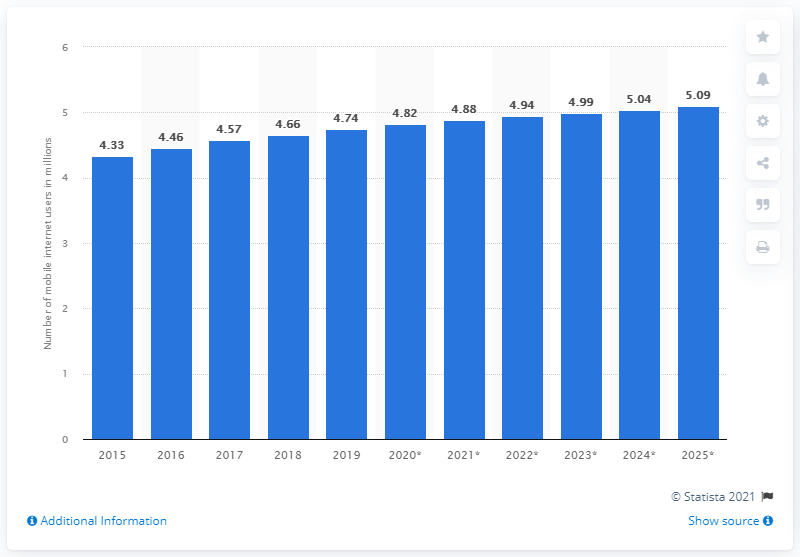Give some essential details in this illustration. By 2025, it is projected that there will be approximately 4.74 mobile internet users in Singapore. In 2019, it is estimated that 4.74 people in Singapore accessed the internet through their mobile devices. 